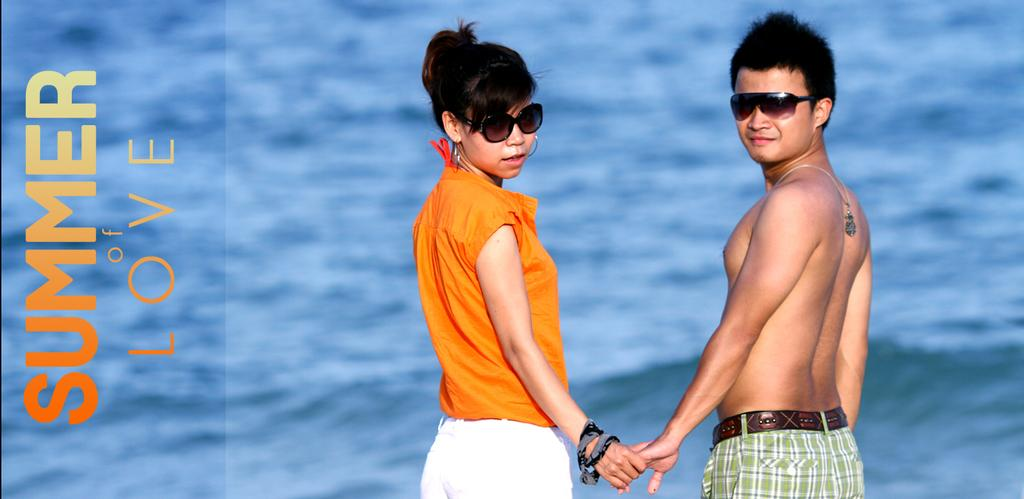How many people are in the image? There are two persons in the image. Where are the persons located in the image? The persons are standing on the sea shore. What are the persons wearing on their faces? The persons are wearing goggles. What can be seen in the background of the image? There is water visible in the image. What is present on the left side of the image? There is text on the left side of the image. What type of animal can be seen interacting with the text on the left side of the image? There is no animal present in the image; it only features two persons standing on the sea shore and wearing goggles, with text on the left side. 